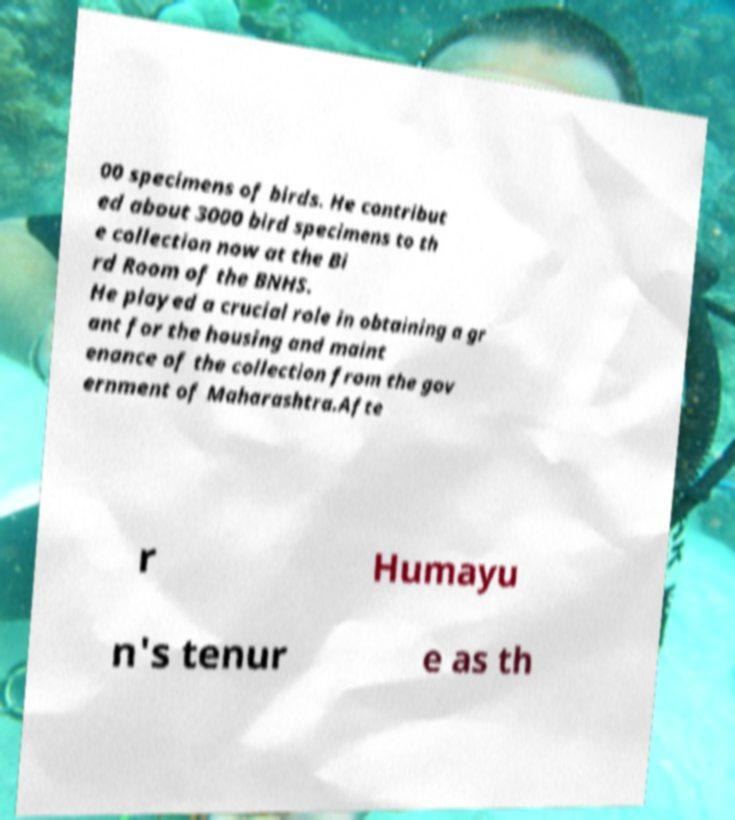What messages or text are displayed in this image? I need them in a readable, typed format. 00 specimens of birds. He contribut ed about 3000 bird specimens to th e collection now at the Bi rd Room of the BNHS. He played a crucial role in obtaining a gr ant for the housing and maint enance of the collection from the gov ernment of Maharashtra.Afte r Humayu n's tenur e as th 